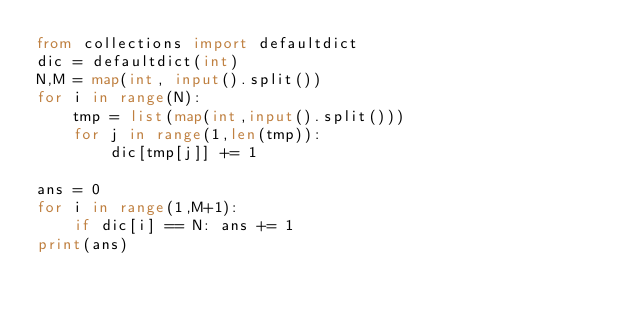<code> <loc_0><loc_0><loc_500><loc_500><_Python_>from collections import defaultdict
dic = defaultdict(int)
N,M = map(int, input().split())
for i in range(N):
    tmp = list(map(int,input().split()))
    for j in range(1,len(tmp)):
        dic[tmp[j]] += 1

ans = 0
for i in range(1,M+1):
    if dic[i] == N: ans += 1
print(ans)</code> 